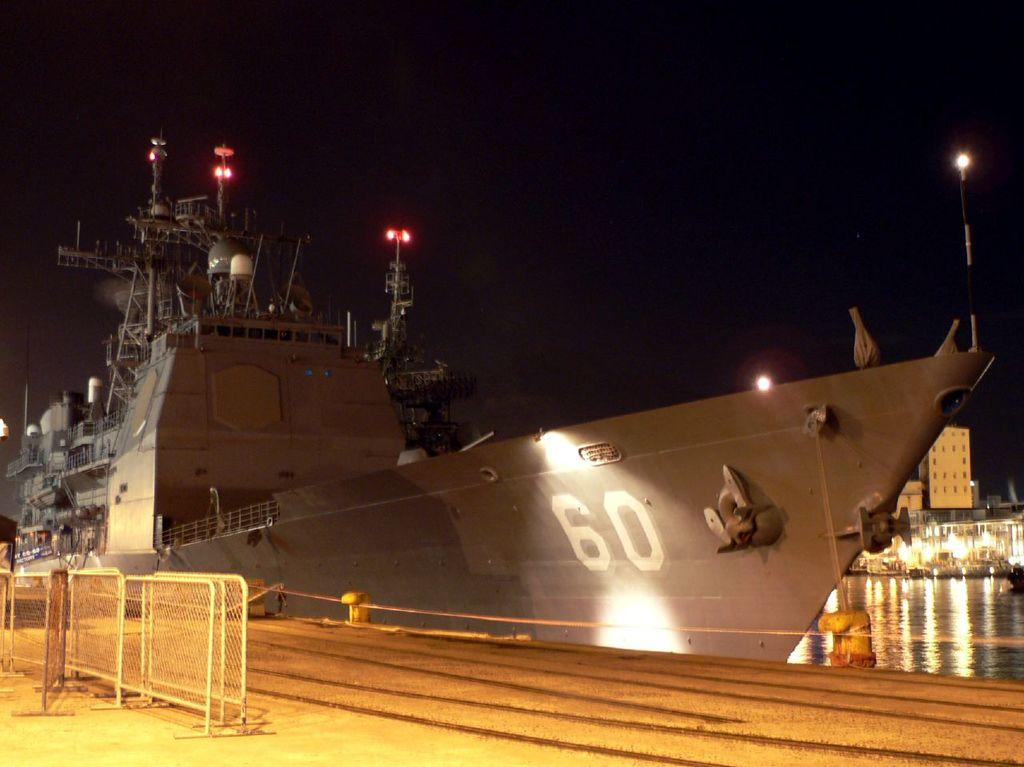<image>
Summarize the visual content of the image. Large gray ship docked with the number 60 on the side. 